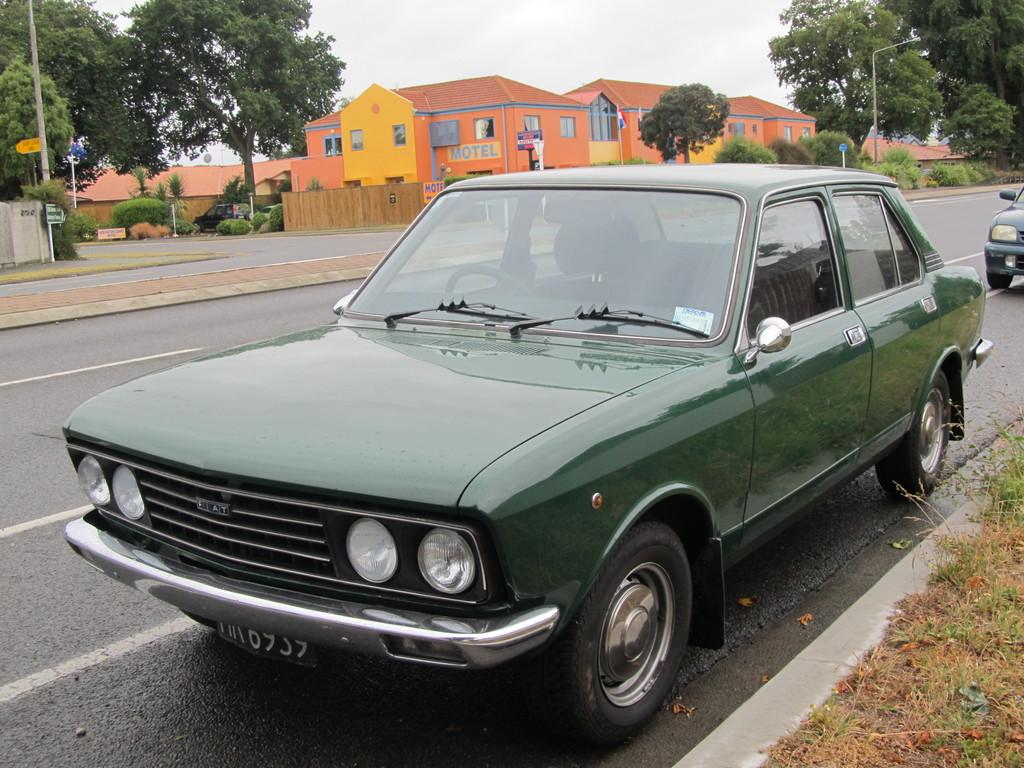What type of vehicles can be seen on the road in the image? There are cars on the road in the image. What type of vegetation is visible in the image? Grass is visible in the image, and there are also trees and plants in the background. What type of structures can be seen in the background? There are houses in the background. What else can be seen in the background of the image? Poles and the sky are visible in the background. Can you tell me how many cacti are growing on the poles in the image? There are no cacti present in the image; the poles are not associated with any plants. What type of can is visible in the image? There is no can present in the image. 